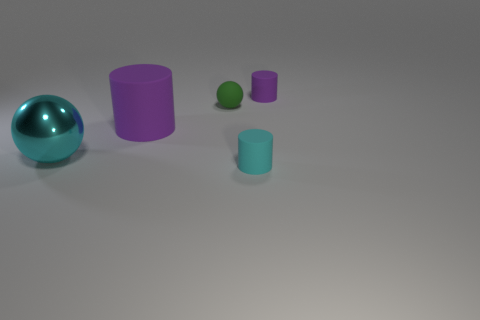What color is the tiny object that is both on the right side of the green object and behind the large metal ball?
Keep it short and to the point. Purple. What number of objects are either purple cylinders behind the large matte cylinder or purple rubber objects?
Ensure brevity in your answer.  2. There is a big shiny thing that is the same shape as the green rubber object; what color is it?
Ensure brevity in your answer.  Cyan. Does the big shiny thing have the same shape as the big object that is behind the big sphere?
Provide a short and direct response. No. What number of things are small purple cylinders that are to the right of the big cylinder or small green spheres that are behind the tiny cyan rubber object?
Offer a very short reply. 2. Is the number of tiny matte things that are in front of the big purple object less than the number of tiny rubber spheres?
Your answer should be compact. No. Are the small green ball and the purple cylinder that is behind the big cylinder made of the same material?
Give a very brief answer. Yes. What is the material of the tiny cyan thing?
Make the answer very short. Rubber. The purple cylinder that is on the left side of the cylinder in front of the object that is left of the big purple rubber cylinder is made of what material?
Provide a succinct answer. Rubber. Does the big cylinder have the same color as the small cylinder in front of the small matte ball?
Give a very brief answer. No. 